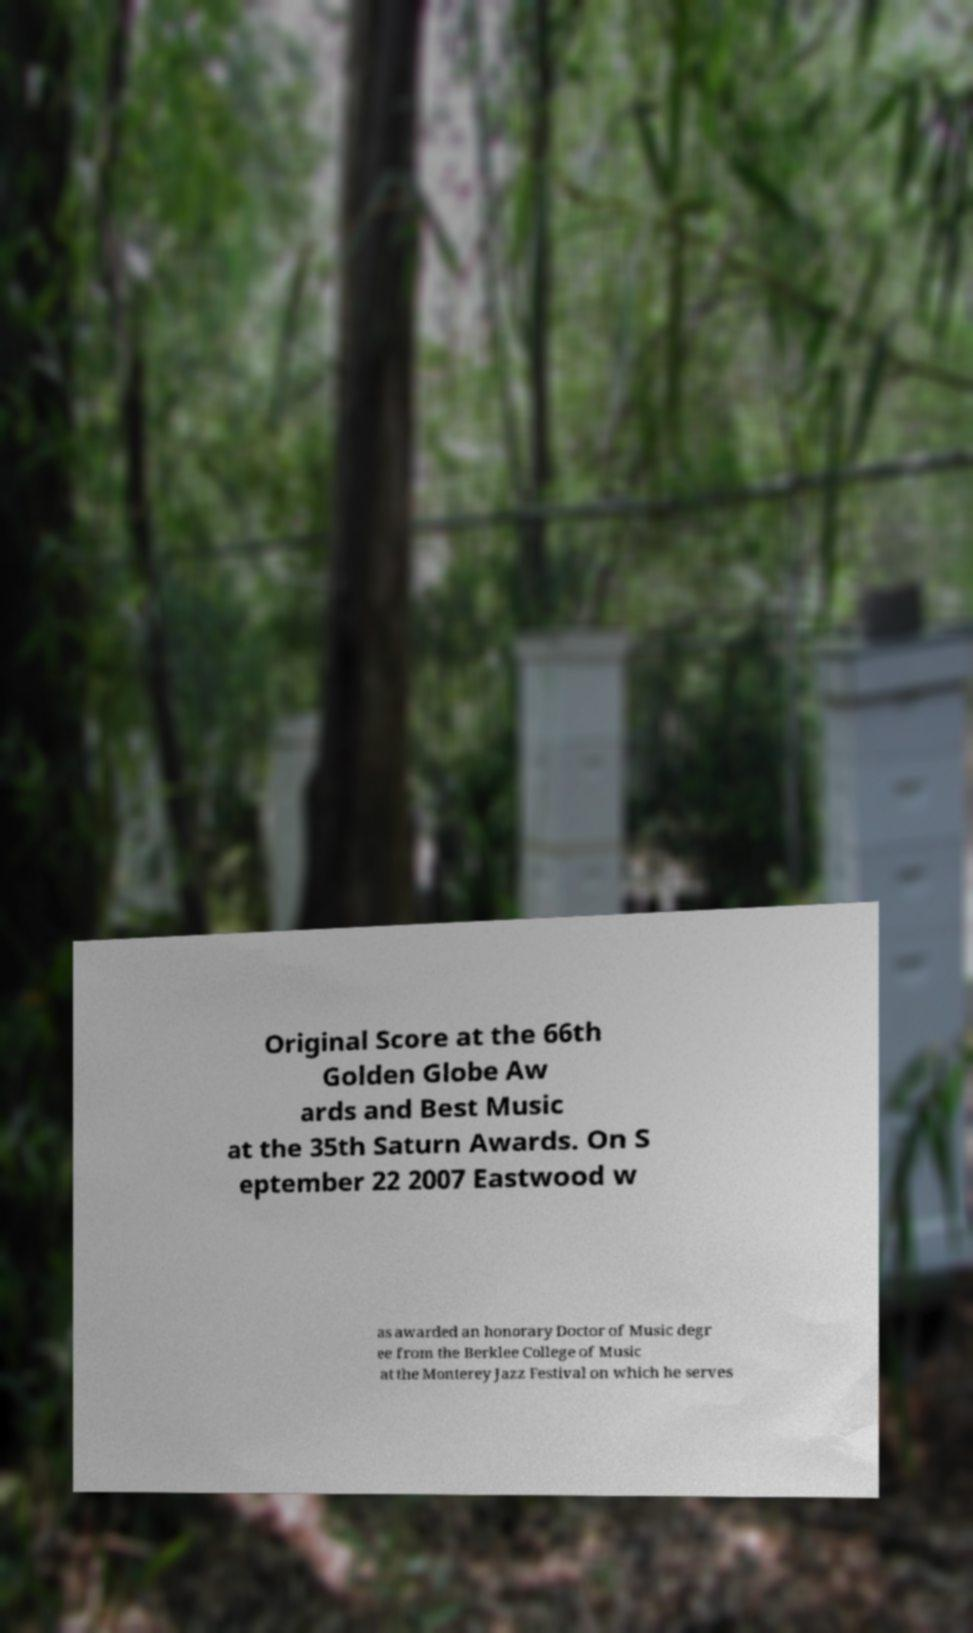What messages or text are displayed in this image? I need them in a readable, typed format. Original Score at the 66th Golden Globe Aw ards and Best Music at the 35th Saturn Awards. On S eptember 22 2007 Eastwood w as awarded an honorary Doctor of Music degr ee from the Berklee College of Music at the Monterey Jazz Festival on which he serves 